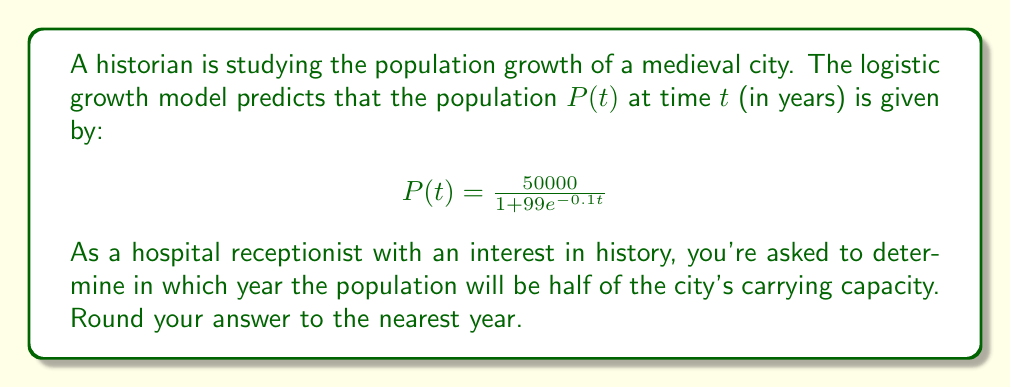Teach me how to tackle this problem. Let's approach this step-by-step:

1) The logistic growth model is given by:
   $$P(t) = \frac{K}{1 + (K/P_0 - 1)e^{-rt}}$$
   where $K$ is the carrying capacity, $P_0$ is the initial population, and $r$ is the growth rate.

2) Comparing our given equation to this general form, we can see that:
   $K = 50000$ (the carrying capacity)
   $K/P_0 - 1 = 99$, so $P_0 \approx 500$
   $r = 0.1$

3) We need to find when $P(t) = K/2 = 25000$

4) Substituting this into our equation:
   $$25000 = \frac{50000}{1 + 99e^{-0.1t}}$$

5) Simplifying:
   $$1 + 99e^{-0.1t} = 2$$
   $$99e^{-0.1t} = 1$$
   $$e^{-0.1t} = \frac{1}{99}$$

6) Taking natural log of both sides:
   $$-0.1t = \ln(\frac{1}{99})$$
   $$t = -10\ln(\frac{1}{99}) \approx 46.05$$

7) Rounding to the nearest year gives us 46 years.
Answer: 46 years 